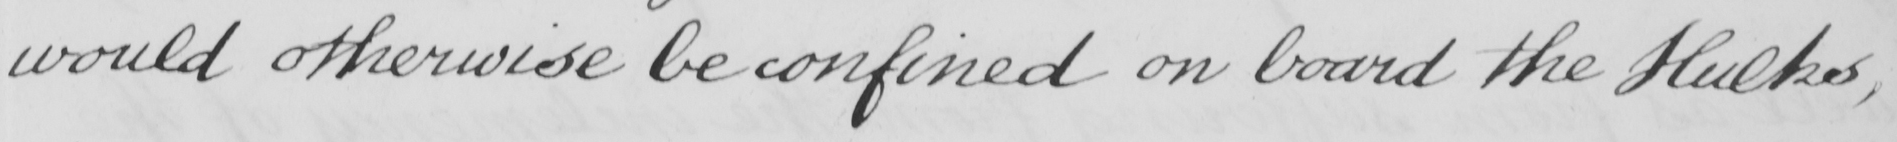Please transcribe the handwritten text in this image. would otherwise be confined on board the Hulks , 